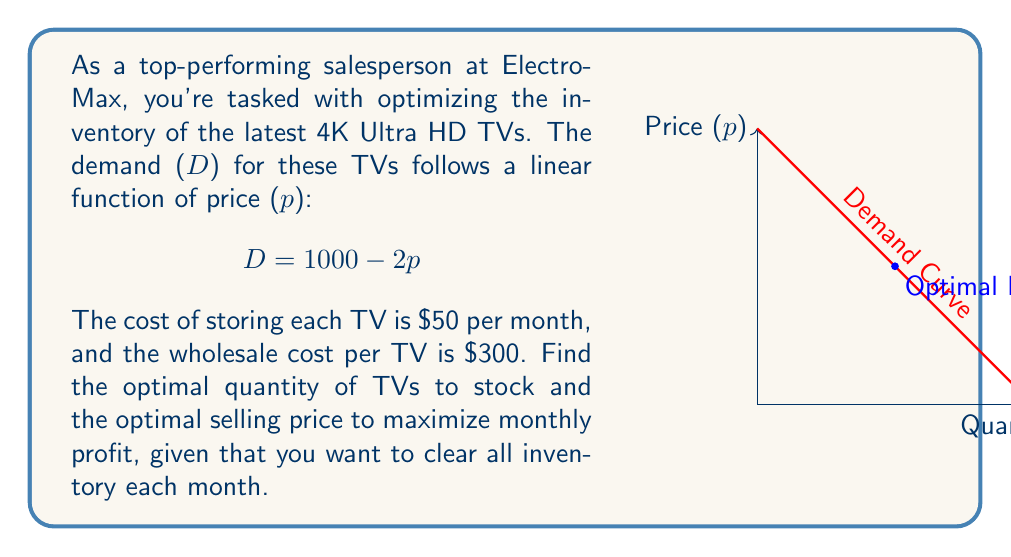What is the answer to this math problem? Let's approach this step-by-step:

1) First, we need to express quantity (q) in terms of price (p):
   $q = 1000 - 2p$

2) The revenue function is price times quantity:
   $R = pq = p(1000 - 2p) = 1000p - 2p^2$

3) The total cost function includes the wholesale cost and storage cost:
   $C = 300q + 50q = 350q = 350(1000 - 2p) = 350000 - 700p$

4) The profit function is revenue minus cost:
   $P = R - C = (1000p - 2p^2) - (350000 - 700p) = -2p^2 + 1700p - 350000$

5) To maximize profit, we differentiate P with respect to p and set it to zero:
   $\frac{dP}{dp} = -4p + 1700 = 0$
   $4p = 1700$
   $p = 425$

6) The second derivative is negative (-4), confirming this is a maximum.

7) Now we can calculate the optimal quantity:
   $q = 1000 - 2(425) = 150$

8) To verify the profit is positive:
   $P = -2(425)^2 + 1700(425) - 350000 = 31250$

Therefore, the optimal selling price is $425, and the optimal quantity to stock is 150 TVs.
Answer: Optimal price: $425; Optimal quantity: 150 TVs 